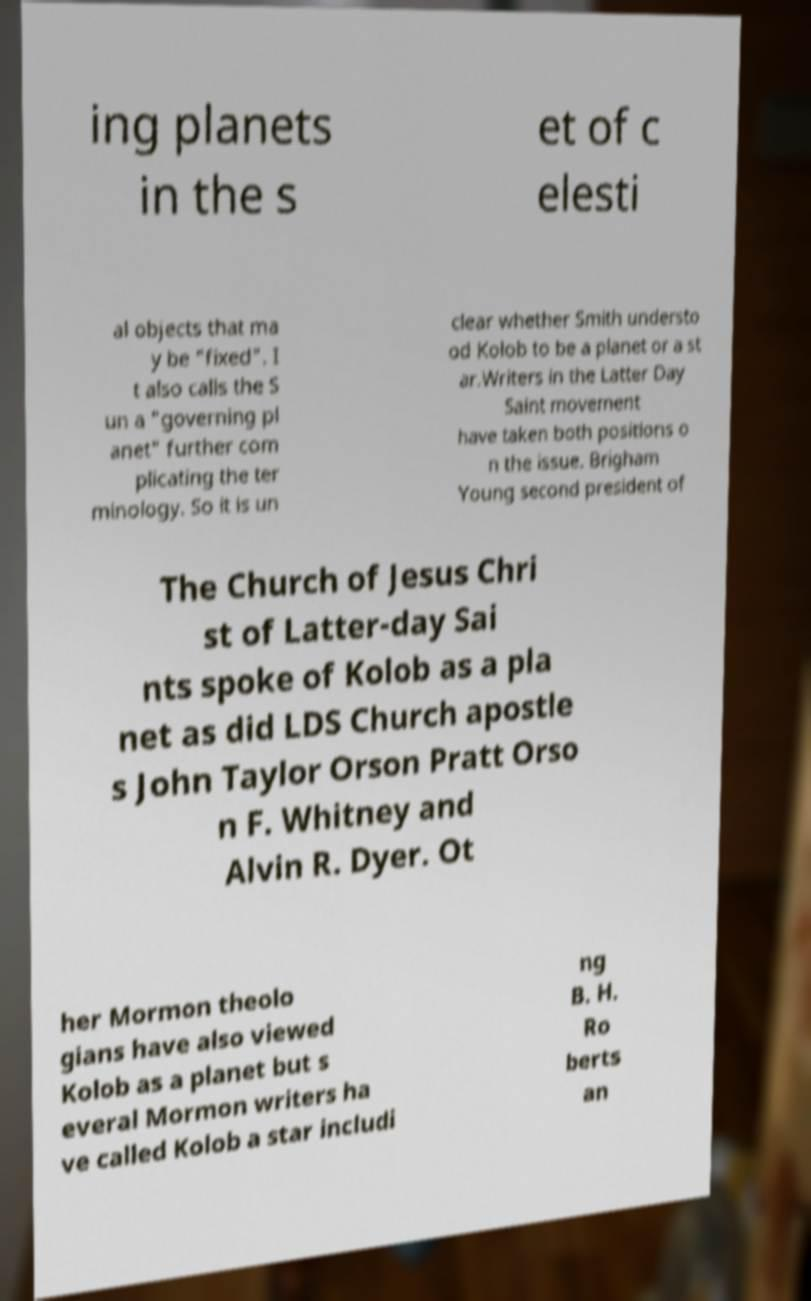Please identify and transcribe the text found in this image. ing planets in the s et of c elesti al objects that ma y be "fixed". I t also calls the S un a "governing pl anet" further com plicating the ter minology. So it is un clear whether Smith understo od Kolob to be a planet or a st ar.Writers in the Latter Day Saint movement have taken both positions o n the issue. Brigham Young second president of The Church of Jesus Chri st of Latter-day Sai nts spoke of Kolob as a pla net as did LDS Church apostle s John Taylor Orson Pratt Orso n F. Whitney and Alvin R. Dyer. Ot her Mormon theolo gians have also viewed Kolob as a planet but s everal Mormon writers ha ve called Kolob a star includi ng B. H. Ro berts an 